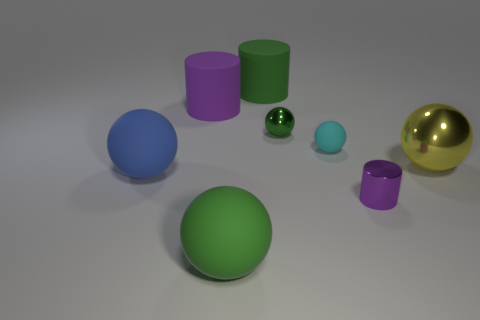Is the color of the small matte thing the same as the large shiny thing?
Make the answer very short. No. Is the number of large yellow objects that are to the left of the blue sphere less than the number of tiny cyan balls?
Ensure brevity in your answer.  Yes. There is a green matte object that is in front of the large purple rubber object that is on the left side of the small matte object; what size is it?
Provide a short and direct response. Large. Is the color of the metal cylinder the same as the large sphere on the left side of the large purple matte object?
Your response must be concise. No. What is the material of the cyan ball that is the same size as the green metal ball?
Make the answer very short. Rubber. Is the number of big green matte things that are behind the cyan rubber object less than the number of large shiny spheres behind the green metal ball?
Your answer should be very brief. No. There is a purple object left of the metal sphere that is to the left of the small metal cylinder; what shape is it?
Keep it short and to the point. Cylinder. Is there a object?
Your answer should be very brief. Yes. There is a metal ball to the left of the cyan object; what is its color?
Your response must be concise. Green. What is the material of the other large cylinder that is the same color as the metallic cylinder?
Ensure brevity in your answer.  Rubber. 